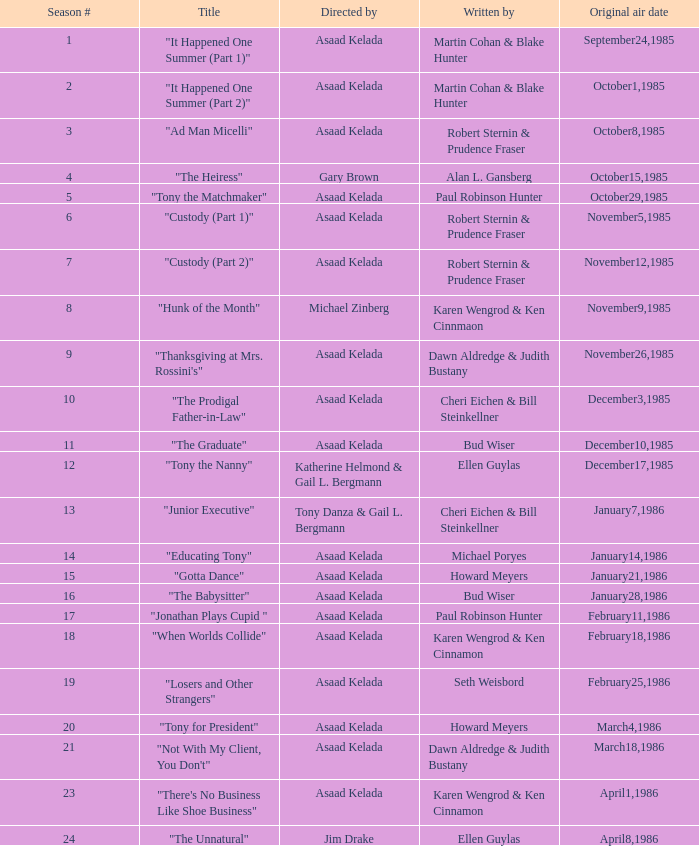What season features writer Michael Poryes? 14.0. 